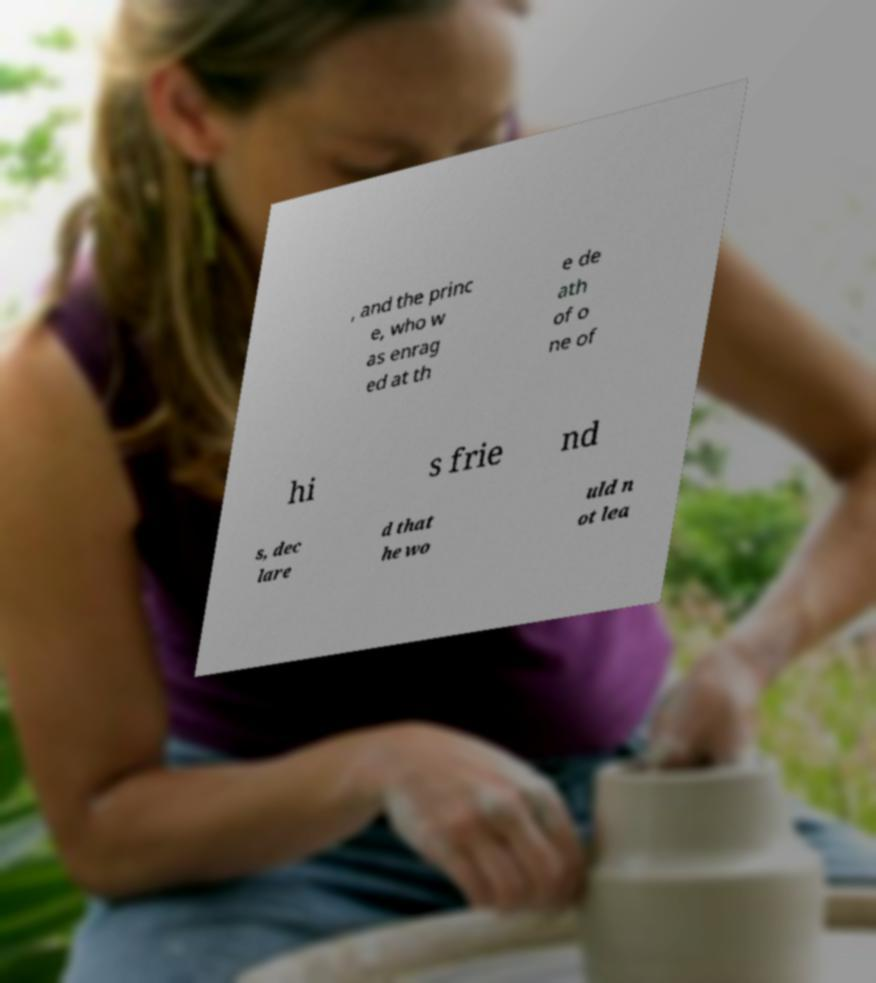Can you read and provide the text displayed in the image?This photo seems to have some interesting text. Can you extract and type it out for me? , and the princ e, who w as enrag ed at th e de ath of o ne of hi s frie nd s, dec lare d that he wo uld n ot lea 